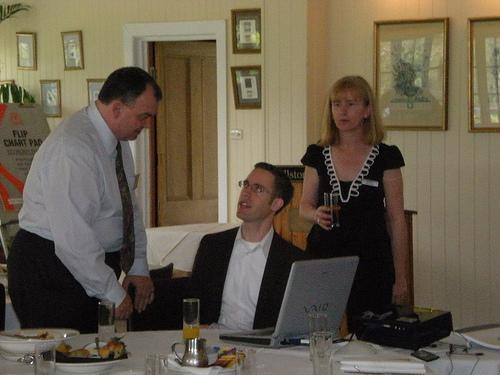Where is this venue likely to be? restaurant 